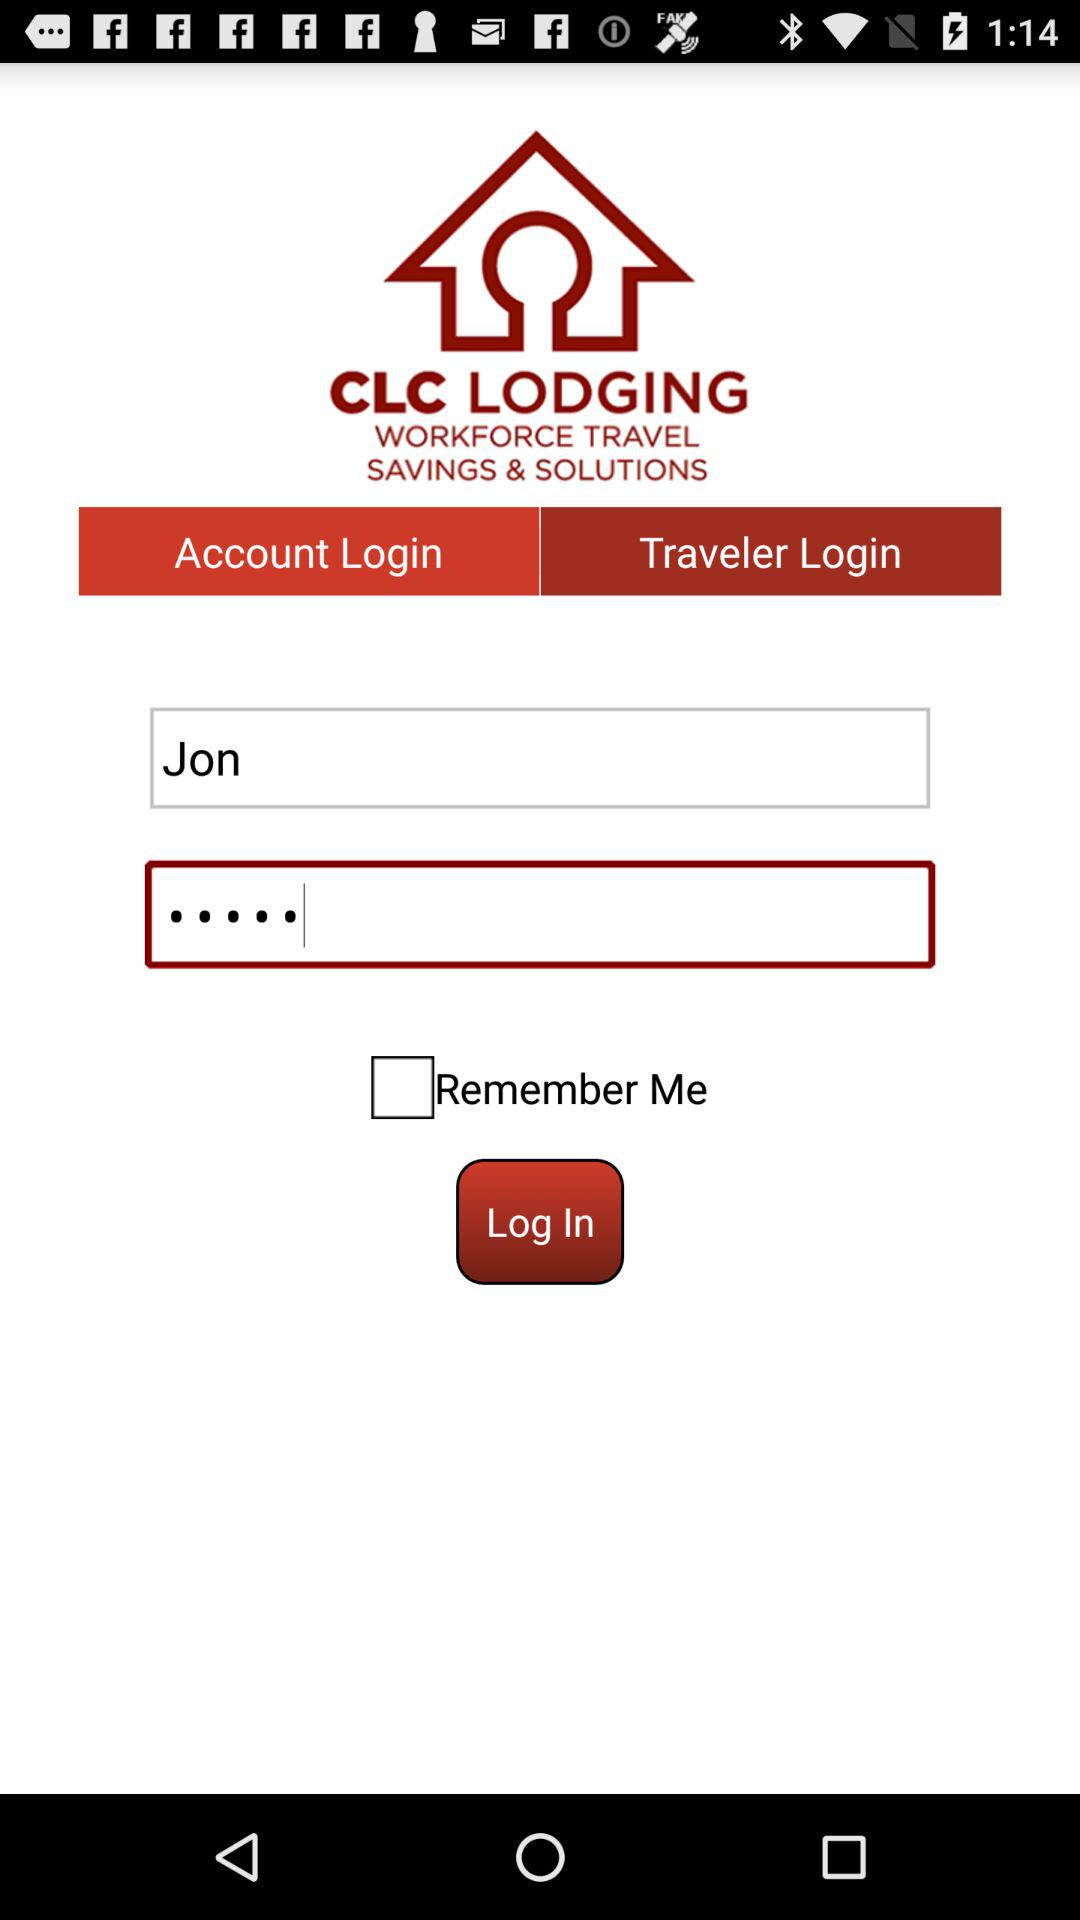What is the application name? The application name is "CLC LODGING". 